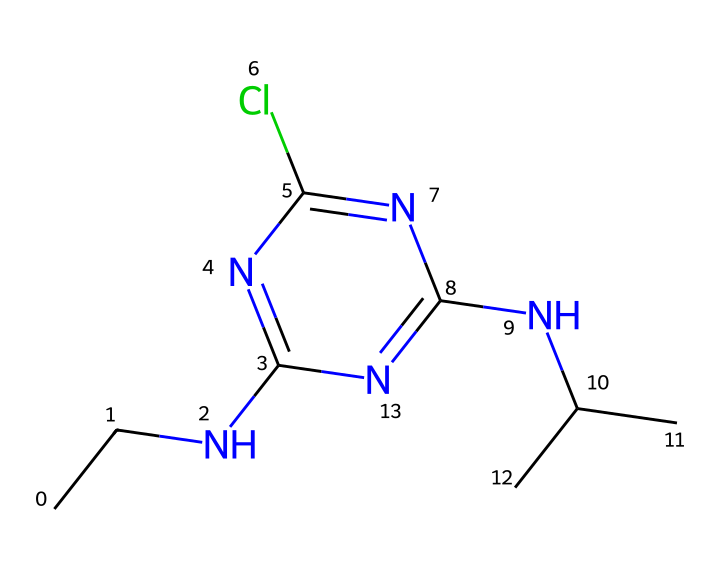What is the molecular formula of atrazine? To find the molecular formula, we count the number of each type of atom in the chemical. The structure shows: 9 carbon (C) atoms, 14 hydrogen (H) atoms, 3 nitrogen (N) atoms, and 1 chlorine (Cl) atom. Therefore, the molecular formula is C9H14ClN5.
Answer: C9H14ClN5 How many nitrogen atoms are present in atrazine? By examining the SMILES representation, we can see that there are 3 'N' symbols indicating the presence of nitrogen atoms.
Answer: 3 What type of herbicide is atrazine classified as? Atrazine is classified as a triazine herbicide due to its chemical structure, which contains a triazine ring comprised of three nitrogen atoms.
Answer: triazine What is the significance of the chlorine atom in atrazine? Chlorine in atrazine contributes to its herbicidal activity and influences its ability to persist in the environment, which can lead to water contamination concerns.
Answer: contamination What type of bonding is present in atrazine's chemical structure? The chemical structure features covalent bonding due to the connections between the carbon, nitrogen, and chlorine atoms, which share electrons in their bonds.
Answer: covalent Which part of atrazine makes it lipophilic? The presence of multiple carbon chains in its structure gives atrazine its lipophilic characteristics, allowing it to dissolve in lipids and organic solvents.
Answer: carbon chains 